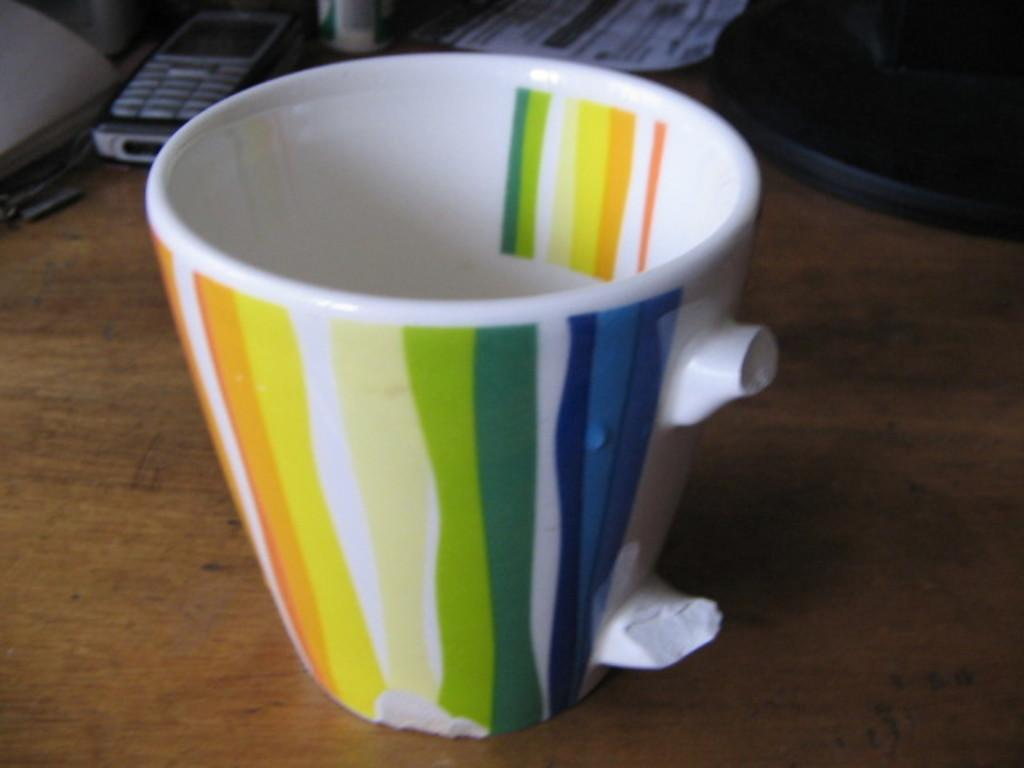What object is present in the image that is typically used for holding liquids? There is a cup in the image that is typically used for holding liquids. What color is the cup in the image? The cup in the image is white in color. What other object can be seen in the image besides the cup? There is a mobile phone in the image. How does the cheese help with the digestion process in the image? There is no cheese present in the image, so it cannot help with any digestion process. 